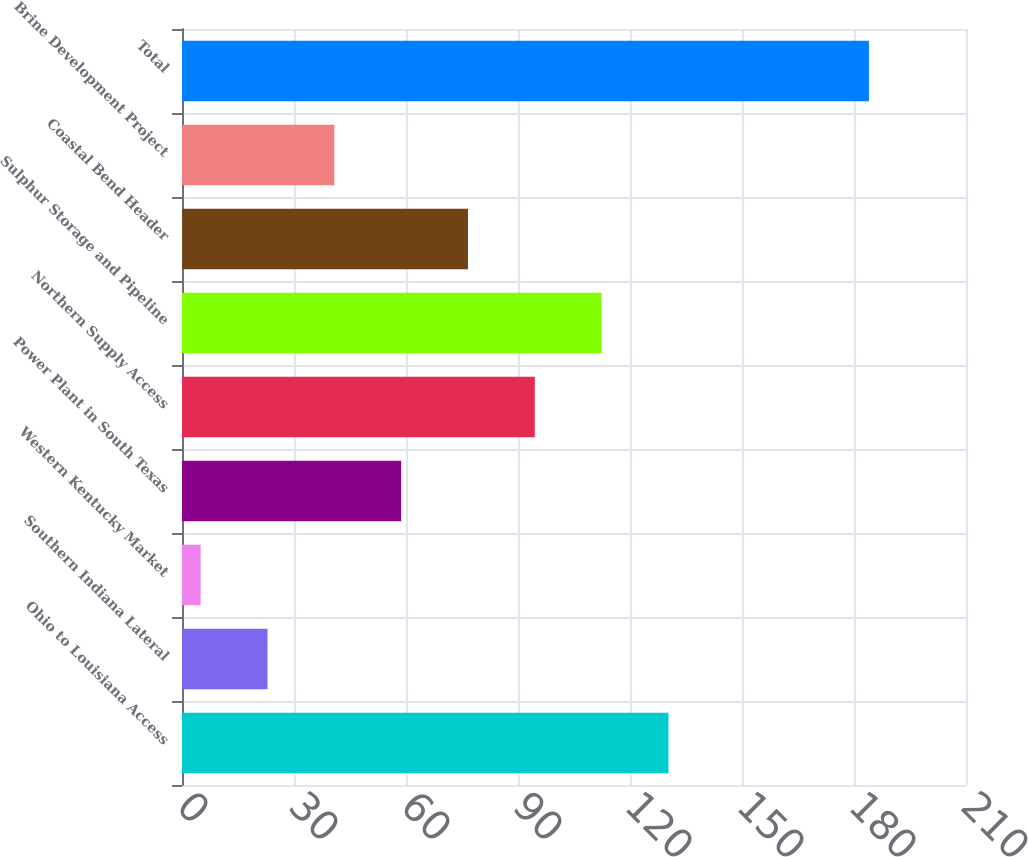Convert chart. <chart><loc_0><loc_0><loc_500><loc_500><bar_chart><fcel>Ohio to Louisiana Access<fcel>Southern Indiana Lateral<fcel>Western Kentucky Market<fcel>Power Plant in South Texas<fcel>Northern Supply Access<fcel>Sulphur Storage and Pipeline<fcel>Coastal Bend Header<fcel>Brine Development Project<fcel>Total<nl><fcel>130.3<fcel>22.9<fcel>5<fcel>58.7<fcel>94.5<fcel>112.4<fcel>76.6<fcel>40.8<fcel>184<nl></chart> 